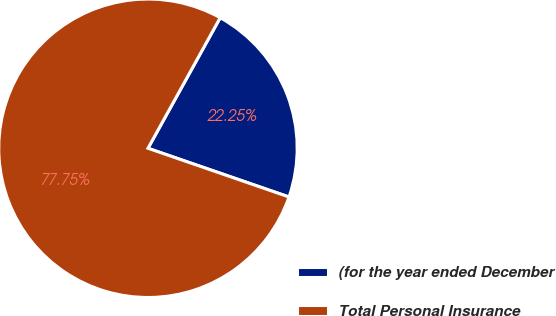Convert chart. <chart><loc_0><loc_0><loc_500><loc_500><pie_chart><fcel>(for the year ended December<fcel>Total Personal Insurance<nl><fcel>22.25%<fcel>77.75%<nl></chart> 